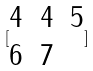<formula> <loc_0><loc_0><loc_500><loc_500>[ \begin{matrix} 4 & 4 & 5 \\ 6 & 7 \end{matrix} ]</formula> 